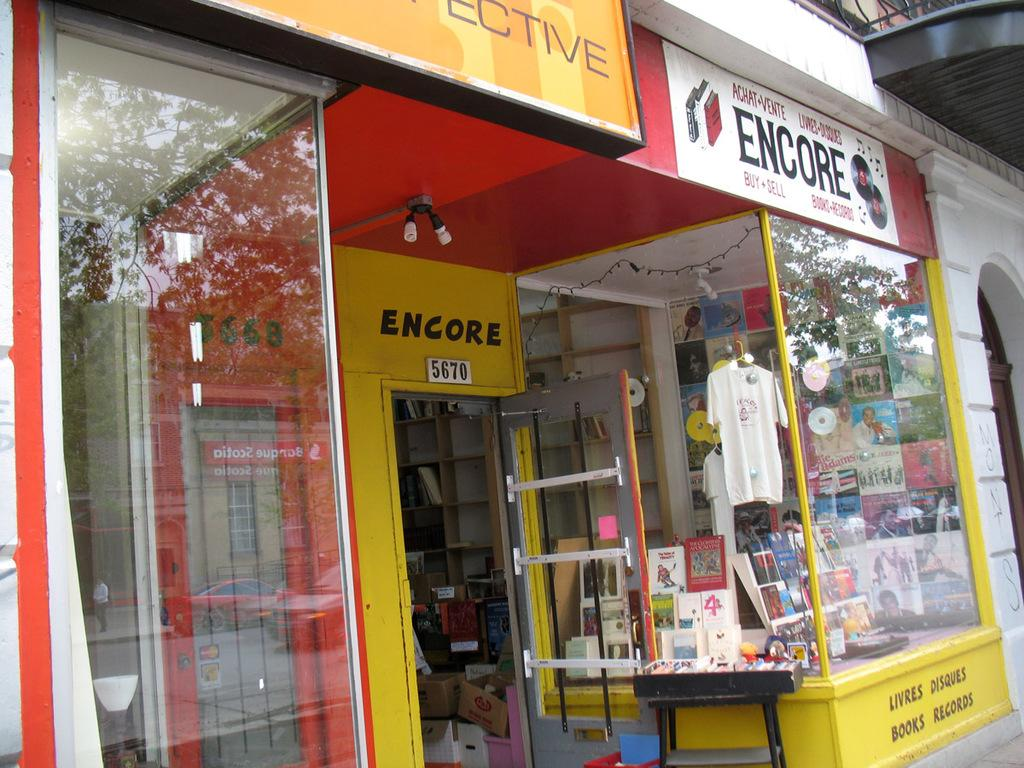<image>
Write a terse but informative summary of the picture. a yellow store front of Encore at 5670 with an open door 